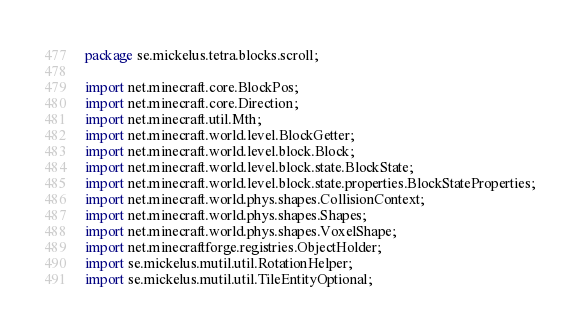<code> <loc_0><loc_0><loc_500><loc_500><_Java_>package se.mickelus.tetra.blocks.scroll;

import net.minecraft.core.BlockPos;
import net.minecraft.core.Direction;
import net.minecraft.util.Mth;
import net.minecraft.world.level.BlockGetter;
import net.minecraft.world.level.block.Block;
import net.minecraft.world.level.block.state.BlockState;
import net.minecraft.world.level.block.state.properties.BlockStateProperties;
import net.minecraft.world.phys.shapes.CollisionContext;
import net.minecraft.world.phys.shapes.Shapes;
import net.minecraft.world.phys.shapes.VoxelShape;
import net.minecraftforge.registries.ObjectHolder;
import se.mickelus.mutil.util.RotationHelper;
import se.mickelus.mutil.util.TileEntityOptional;</code> 